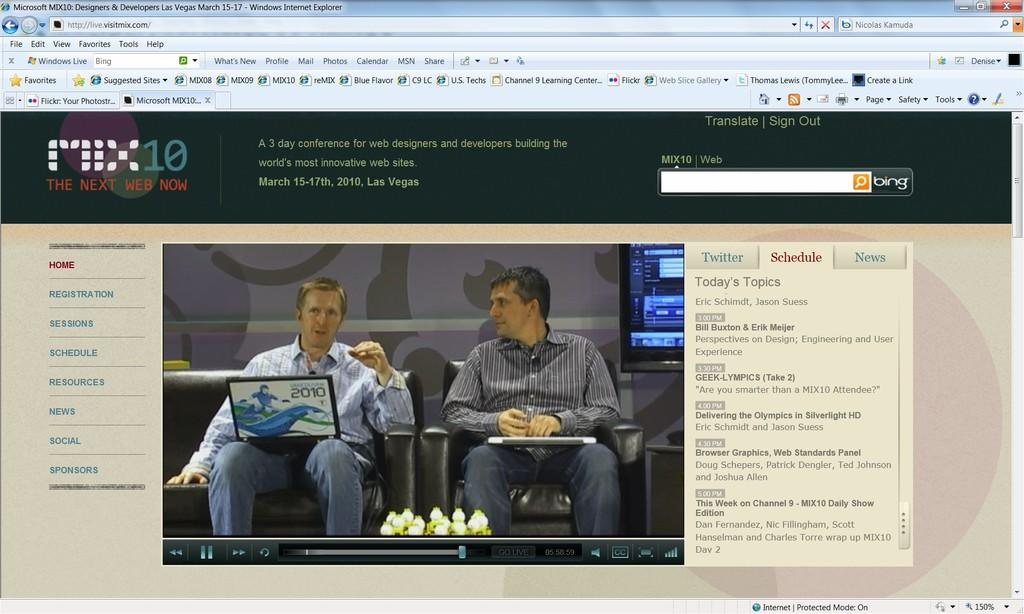What type of image is being described? The image is a picture of a web page. What can be seen on the web page? There are men sitting on chairs in the image. What electronic devices are visible in the image? There are laptops visible in the image. Where is the oven located in the image? There is no oven present in the image. What is the end result of the meeting shown in the image? The image does not depict a meeting or any specific outcome, so it is not possible to determine the end result. 